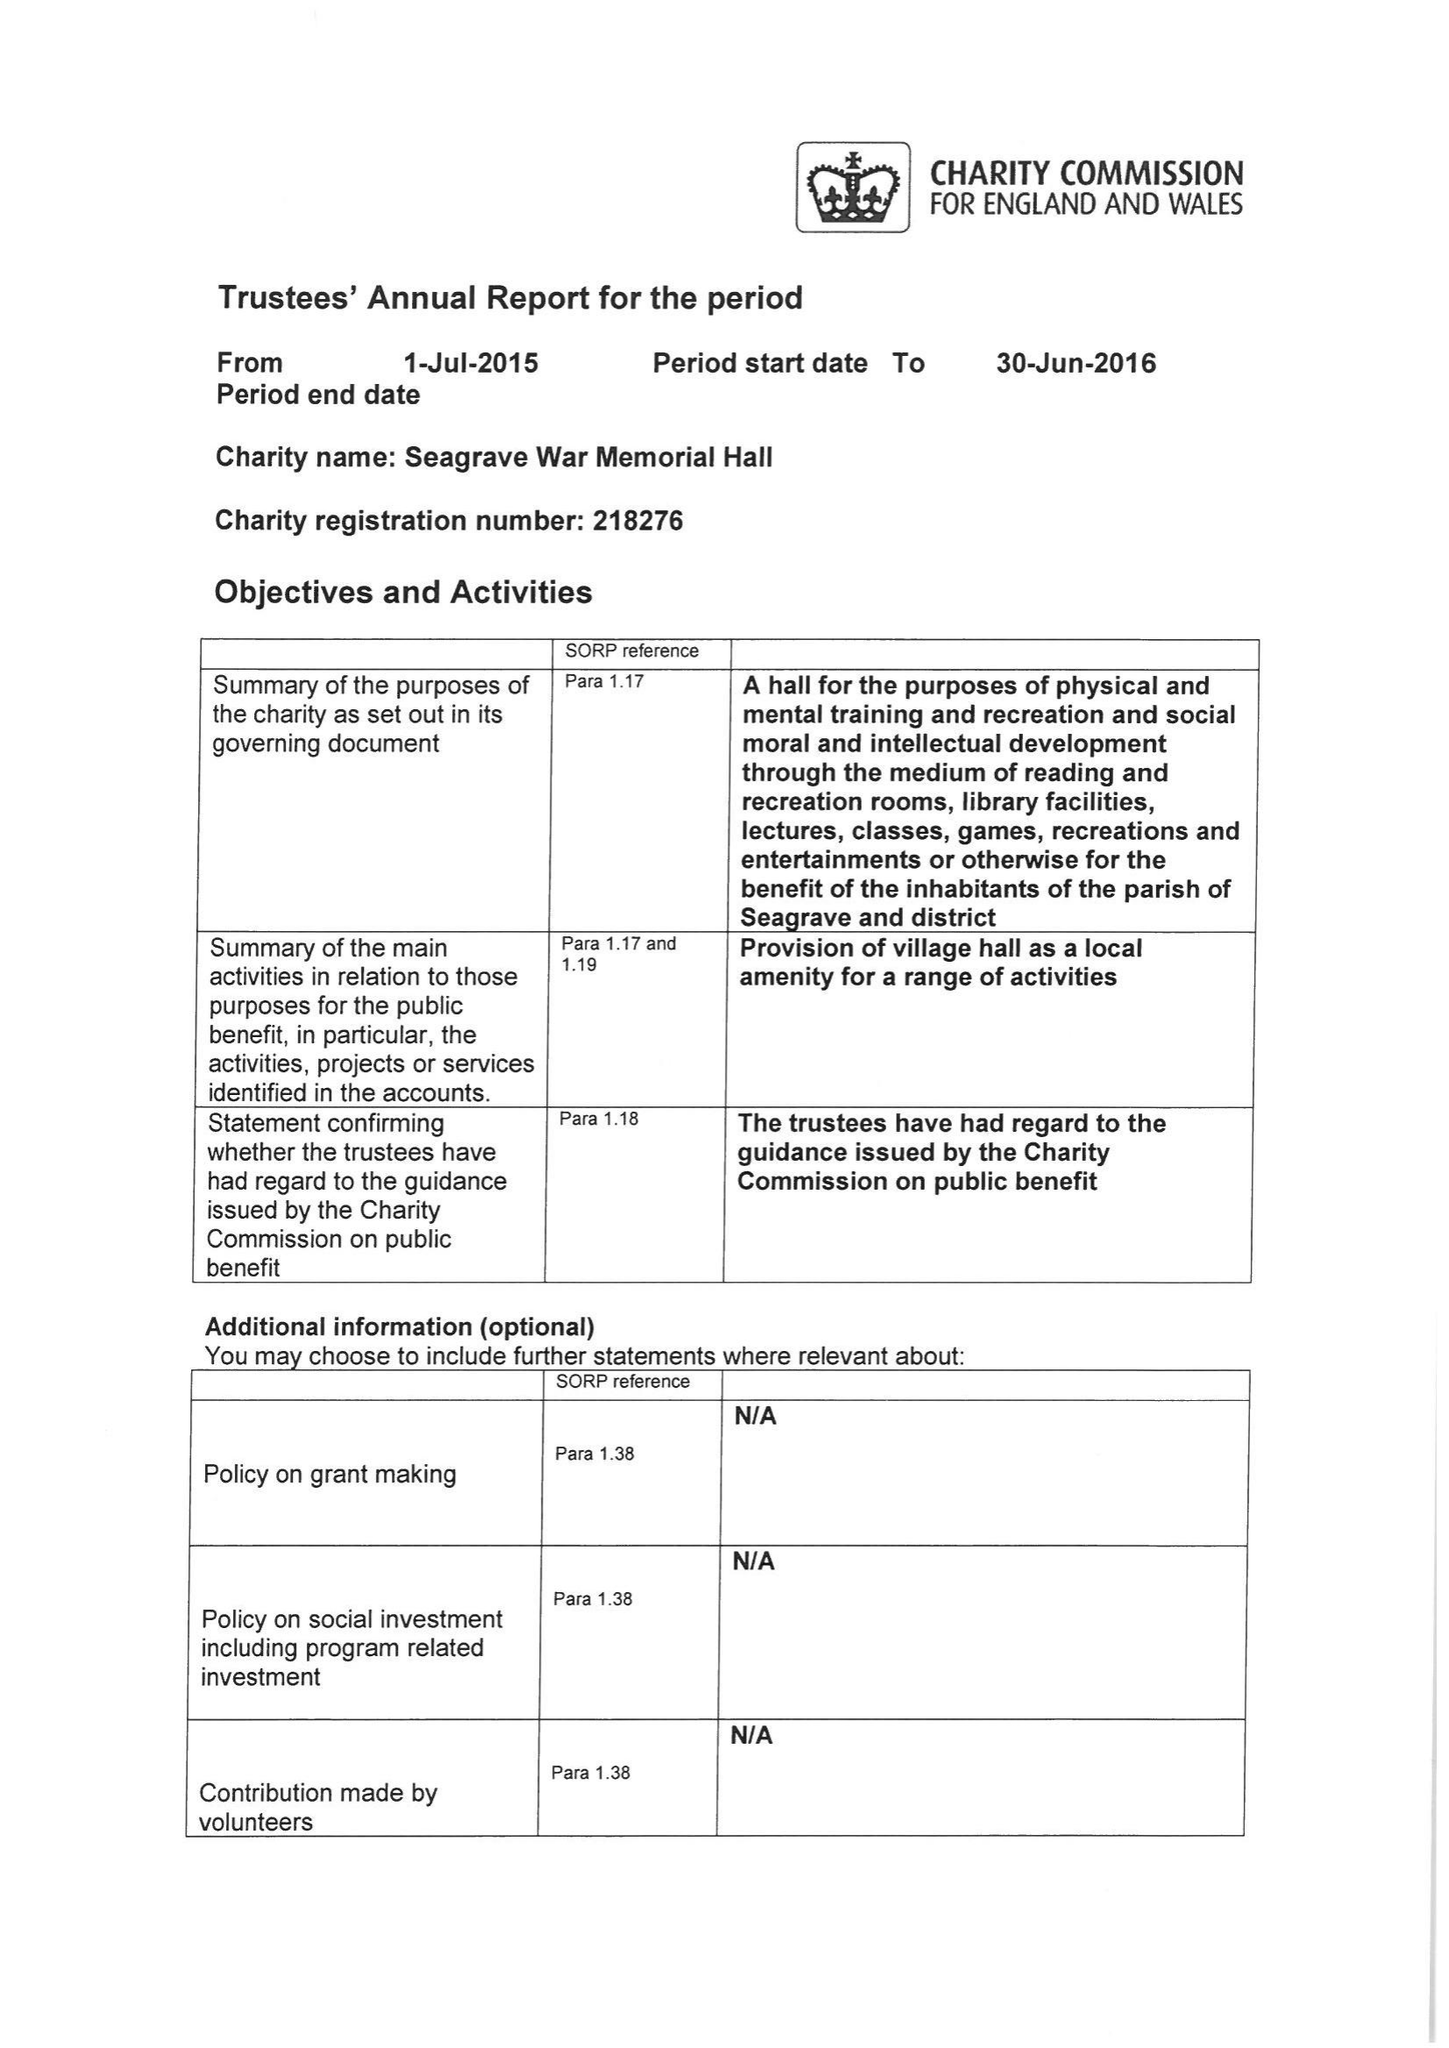What is the value for the address__street_line?
Answer the question using a single word or phrase. GREEN LANE 